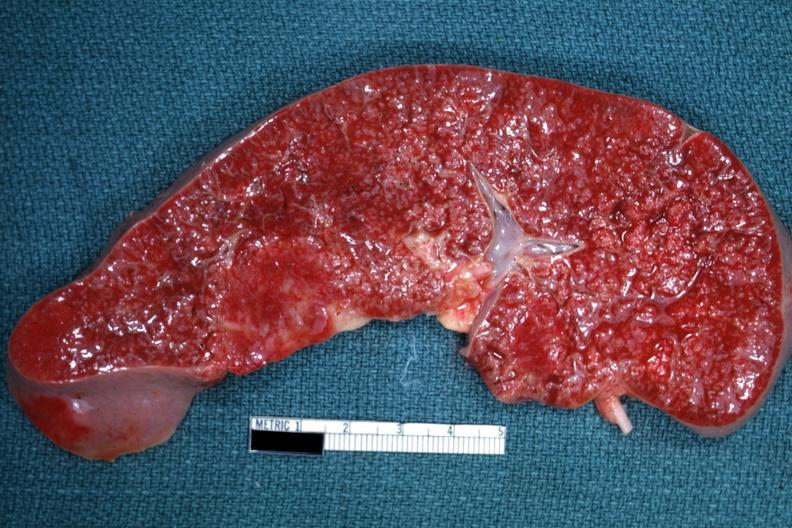s hematologic present?
Answer the question using a single word or phrase. Yes 